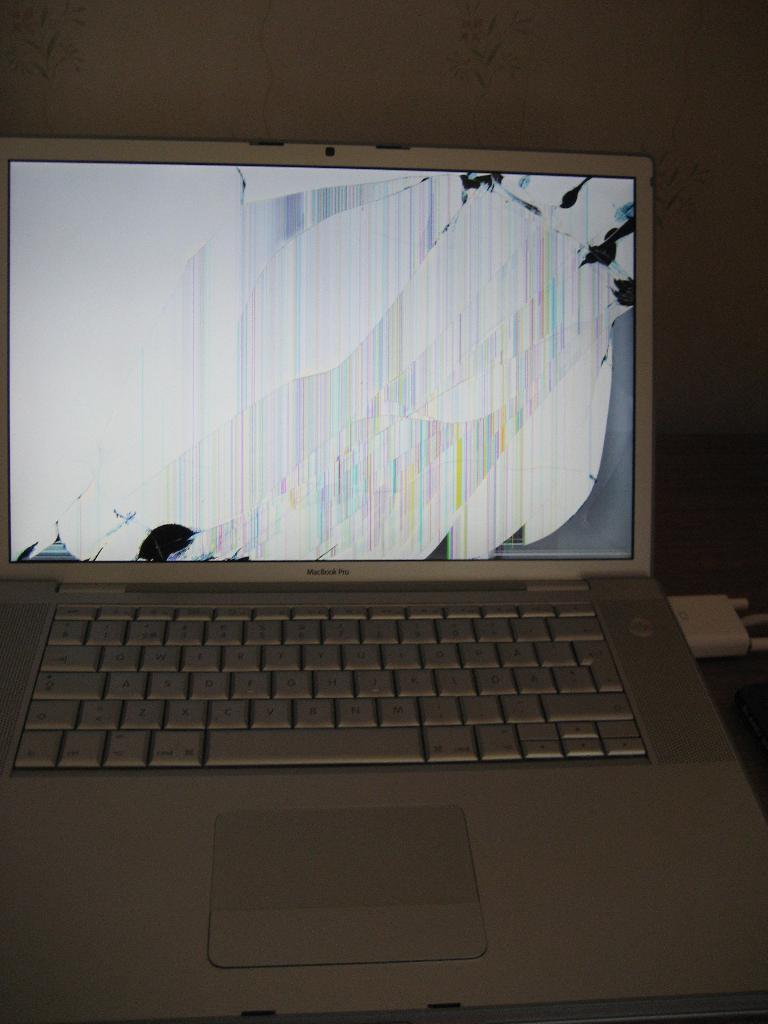What is the brand of this laptop?
Give a very brief answer. Macbook pro. 